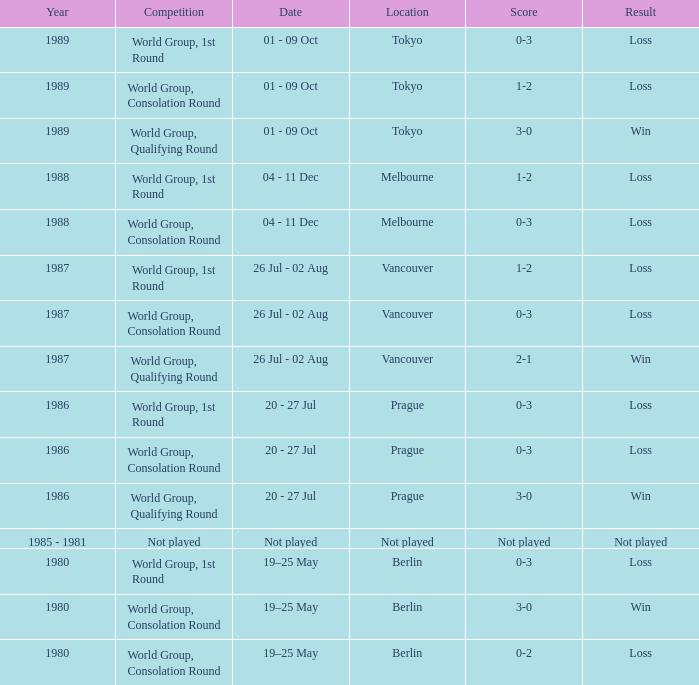In which year is the date not played? 1985 - 1981. 